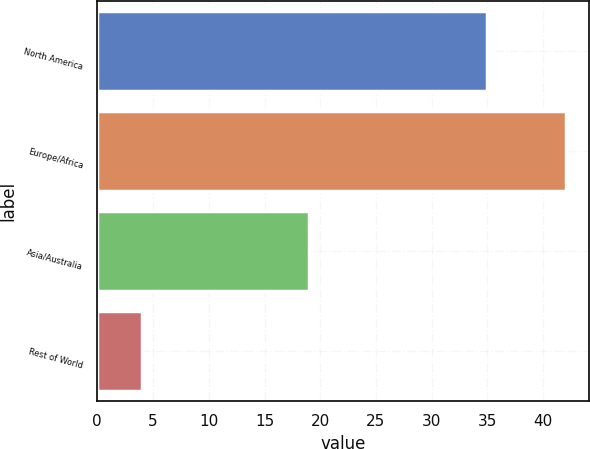Convert chart to OTSL. <chart><loc_0><loc_0><loc_500><loc_500><bar_chart><fcel>North America<fcel>Europe/Africa<fcel>Asia/Australia<fcel>Rest of World<nl><fcel>35<fcel>42<fcel>19<fcel>4<nl></chart> 